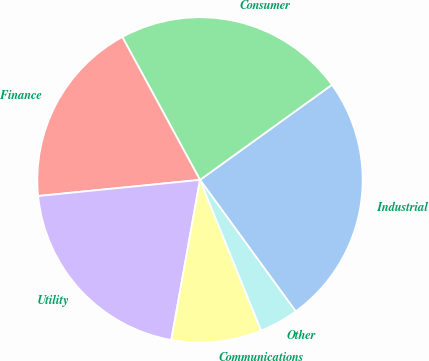Convert chart. <chart><loc_0><loc_0><loc_500><loc_500><pie_chart><fcel>Industrial<fcel>Consumer<fcel>Finance<fcel>Utility<fcel>Communications<fcel>Other<nl><fcel>24.93%<fcel>22.99%<fcel>18.66%<fcel>20.6%<fcel>8.96%<fcel>3.88%<nl></chart> 